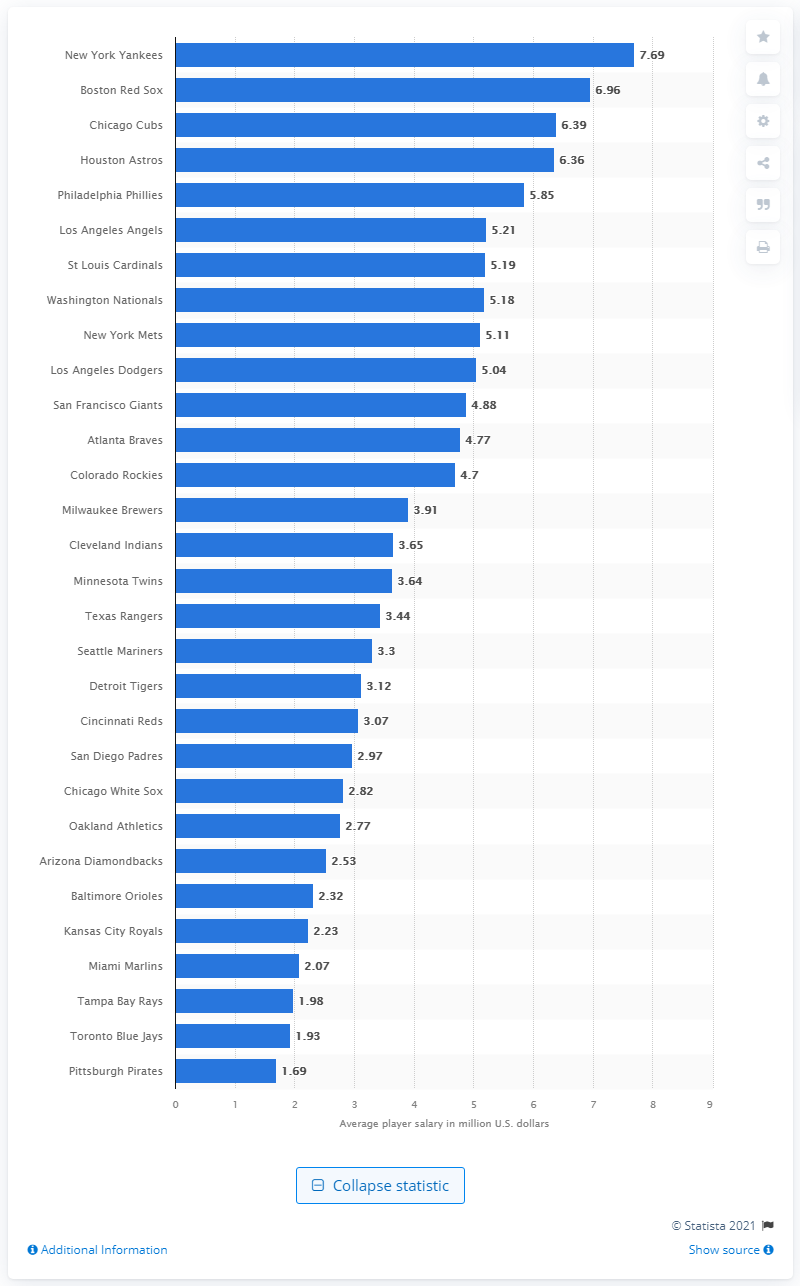Indicate a few pertinent items in this graphic. The average player salary for the New York Yankees in 2019 was 7.69 million dollars. 